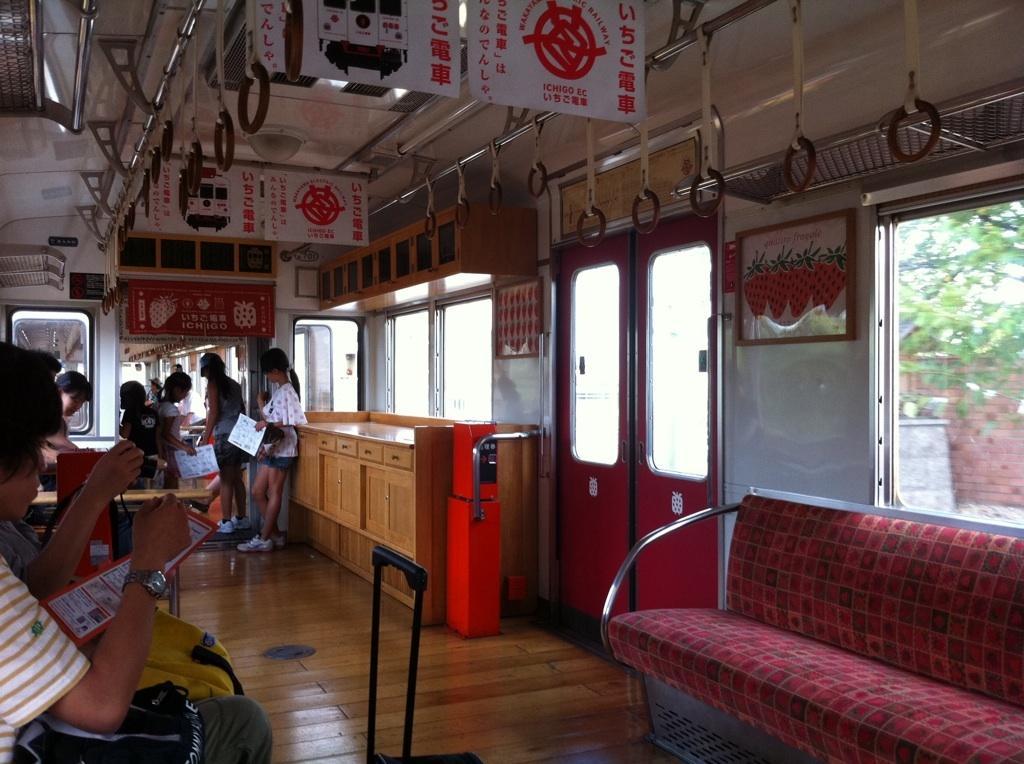Could you give a brief overview of what you see in this image? There is a group of a people. Some persons are standing and some persons are sitting. We can see in the background there is a tree,window and hanger. 